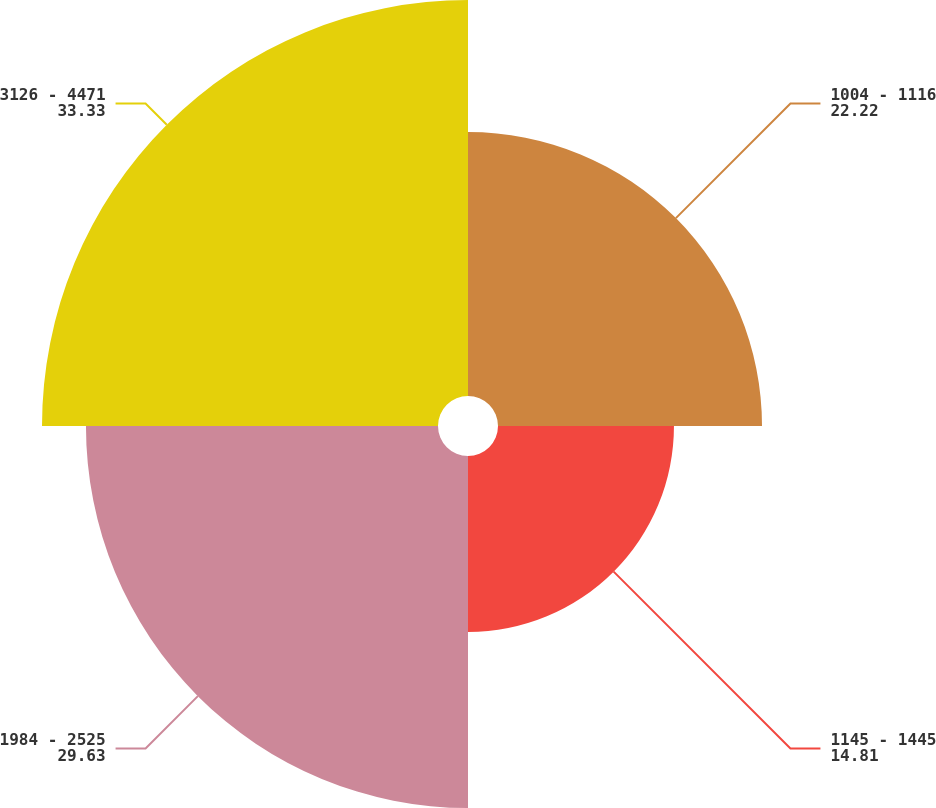<chart> <loc_0><loc_0><loc_500><loc_500><pie_chart><fcel>1004 - 1116<fcel>1145 - 1445<fcel>1984 - 2525<fcel>3126 - 4471<nl><fcel>22.22%<fcel>14.81%<fcel>29.63%<fcel>33.33%<nl></chart> 